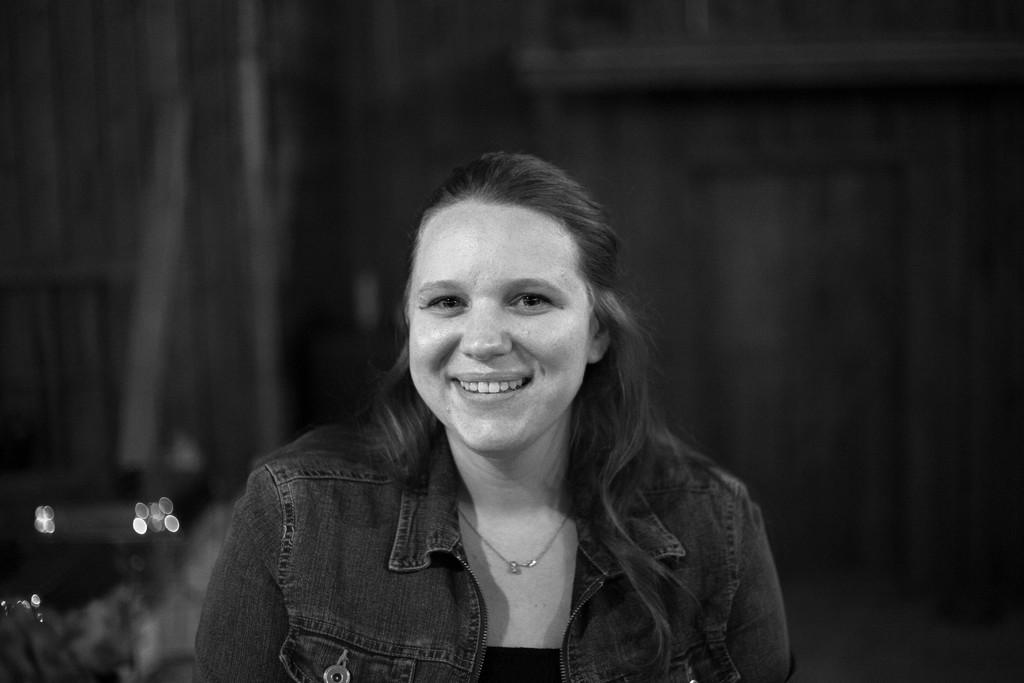Who is present in the image? There is a woman in the image. What is the woman doing in the image? The woman is smiling in the image. What accessory is the woman wearing in the image? The woman is wearing a locket on her neck in the image. What can be said about the color scheme of the image? The image is black and white. How would you describe the background of the image? The background of the image is dark. What type of pin can be seen on the woman's heart in the image? There is no pin or heart visible on the woman in the image; she is only wearing a locket. How many grapes are visible on the woman's necklace in the image? There are no grapes present in the image; the woman is wearing a locket on her neck. 